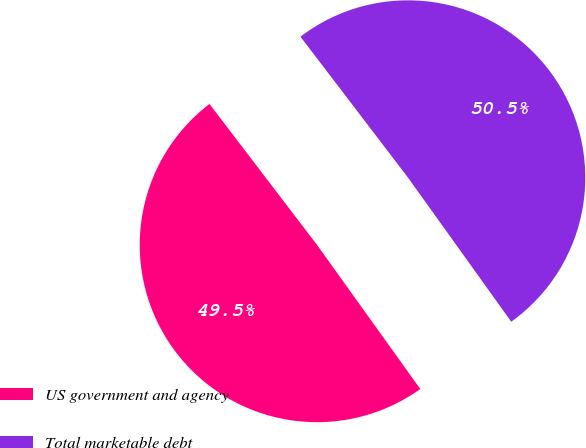Convert chart to OTSL. <chart><loc_0><loc_0><loc_500><loc_500><pie_chart><fcel>US government and agency<fcel>Total marketable debt<nl><fcel>49.52%<fcel>50.48%<nl></chart> 